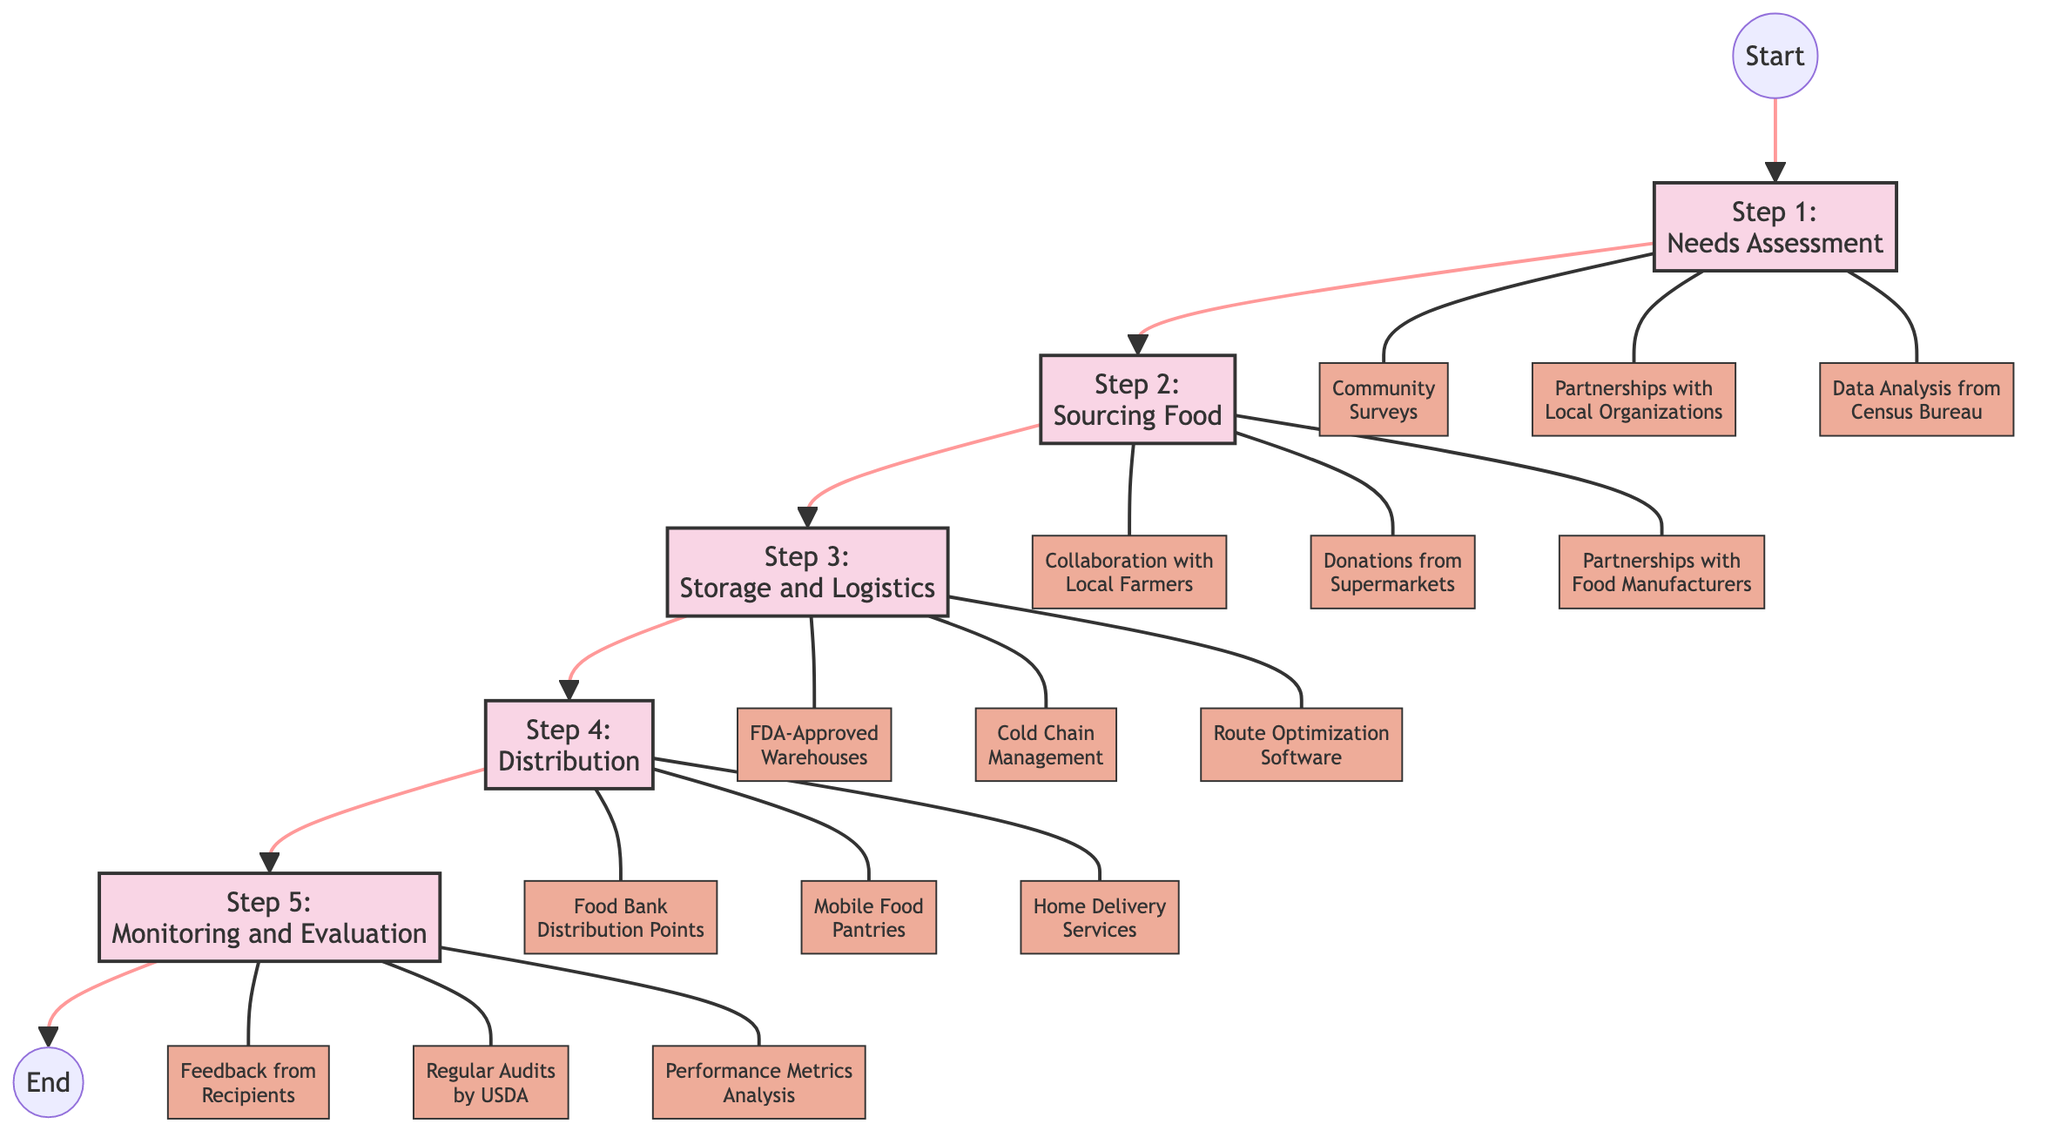what is the first step in the food distribution process? The diagram shows the first step labeled "Step 1: Needs Assessment," which is indicated at the beginning of the pathway.
Answer: Needs Assessment how many total steps are in the food distribution process? By counting the nodes labeled from Steps 1 to 5 in the diagram, there are five distinct steps that make up the food distribution process.
Answer: 5 which step involves cold chain management? Cold chain management is listed as an activity under "Step 3: Storage and Logistics," meaning it pertains to how food is stored and transported.
Answer: Step 3: Storage and Logistics what activities are associated with needs assessment? The diagram presents three activities under Step 1, which include Community Surveys, Partnerships with Local Organizations, and Data Analysis from Census Bureau.
Answer: Community Surveys, Partnerships with Local Organizations, Data Analysis from Census Bureau which step comes after sourcing food? The flow through the diagram indicates that Step 3: Storage and Logistics follows Step 2: Sourcing Food directly in the sequence of the process.
Answer: Step 3: Storage and Logistics what action is taken in the distribution step? The distribution step involves specific activities, such as Food Bank Distribution Points, Mobile Food Pantries, and Home Delivery Services, focusing on delivering food to families in need.
Answer: Food Bank Distribution Points, Mobile Food Pantries, Home Delivery Services how is the effectiveness of the food distribution process assessed? The final step, Step 5: Monitoring and Evaluation, includes activities like Feedback from Recipients, Regular Audits by USDA, and Performance Metrics Analysis to evaluate the process's effectiveness.
Answer: Feedback from Recipients, Regular Audits by USDA, Performance Metrics Analysis list one partnership mentioned in the sourcing food step. The sourcing food step includes partnerships with local farmers, which is specified as one of the activities aimed at securing food sources.
Answer: Partnership with Local Farmers what is the last step in the food distribution process? The diagram clearly indicates that Step 5: Monitoring and Evaluation is the final step, concluding the pathway of the food distribution process.
Answer: Step 5: Monitoring and Evaluation 